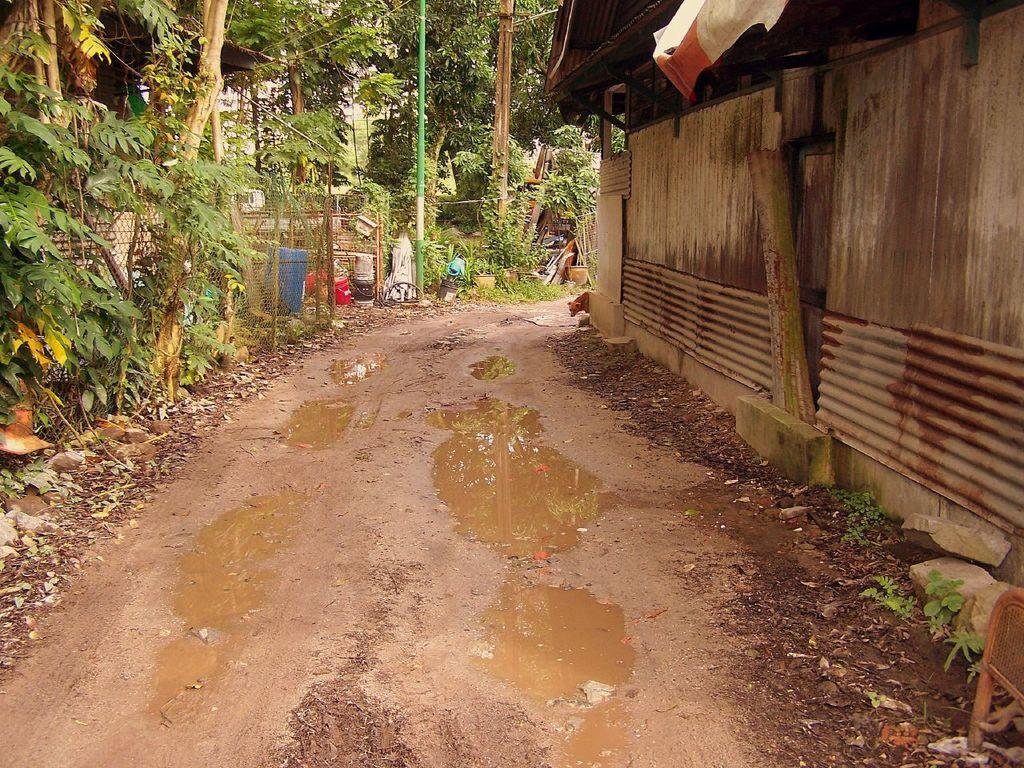What type of natural elements can be seen in the image? Plants, rocks, trees, and water are visible in the image. What type of man-made structures can be seen in the image? There is a shelter and poles visible in the image. What type of material is present in the image? Mesh is present in the image. What type of whip can be seen in the image? There is no whip present in the image. What type of system is being used to control the objects in the image? There is no system present in the image, and the objects are stationary. 